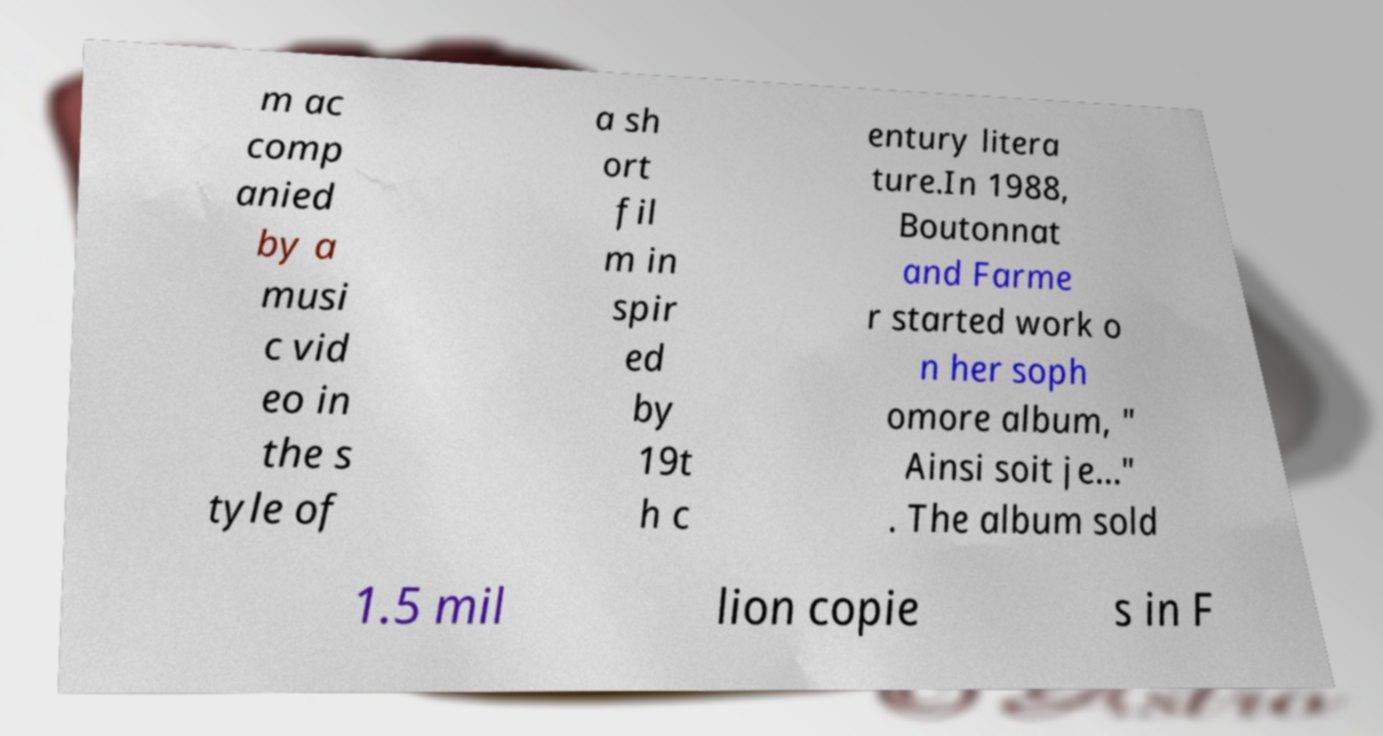What messages or text are displayed in this image? I need them in a readable, typed format. m ac comp anied by a musi c vid eo in the s tyle of a sh ort fil m in spir ed by 19t h c entury litera ture.In 1988, Boutonnat and Farme r started work o n her soph omore album, " Ainsi soit je..." . The album sold 1.5 mil lion copie s in F 